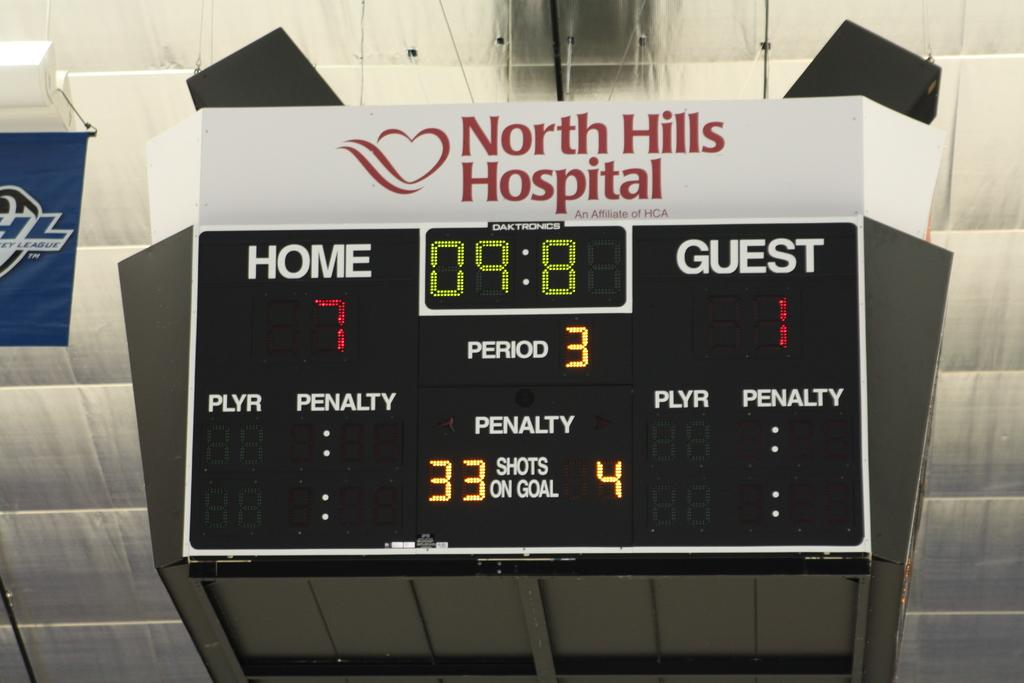<image>
Create a compact narrative representing the image presented. A score board with a North Hills hospital advertisement on it 